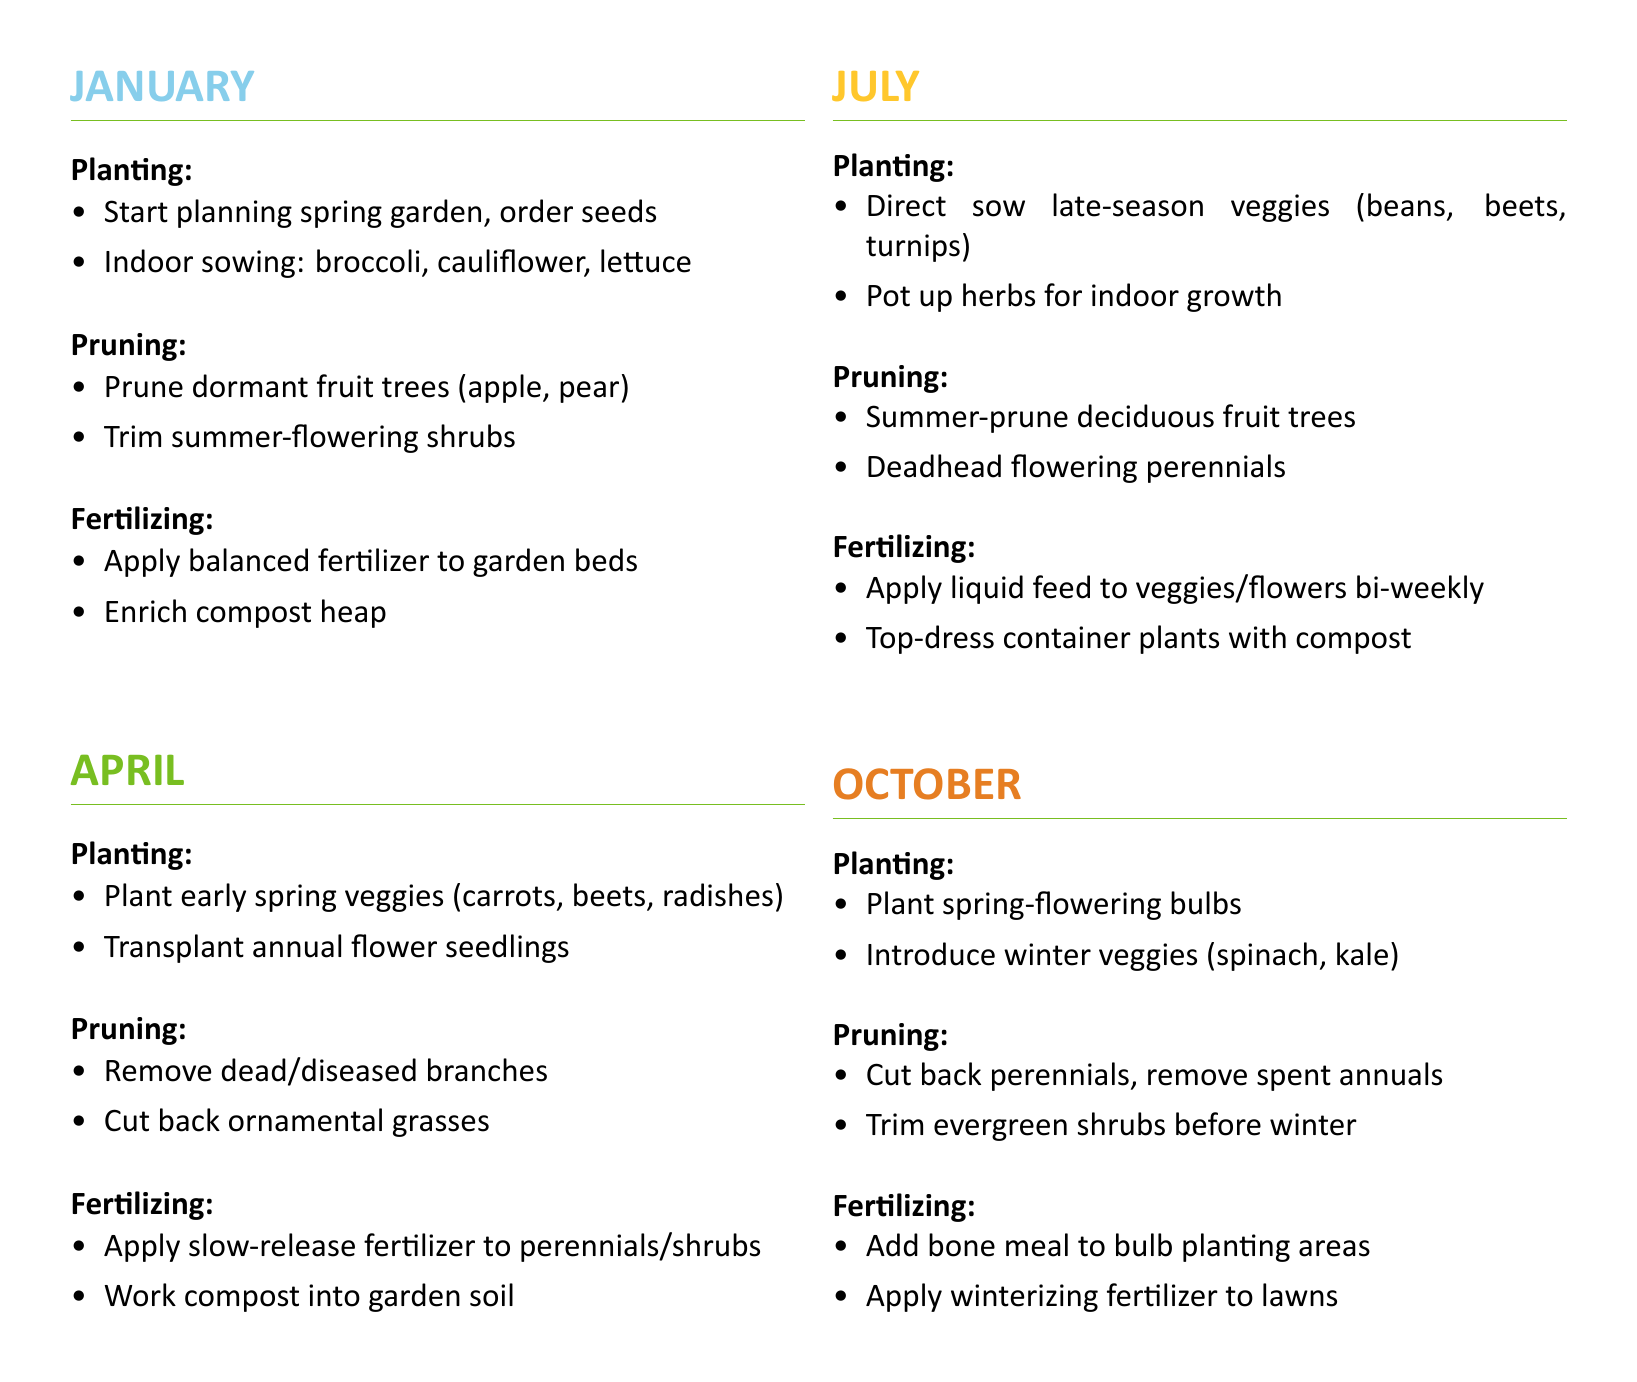What should be sown indoors in January? The document lists broccoli, cauliflower, and lettuce as seeds for indoor sowing in January.
Answer: broccoli, cauliflower, lettuce Which month is associated with planting spring-flowering bulbs? The document indicates that October is the time for planting spring-flowering bulbs.
Answer: October What type of fertilizer is recommended for perennials in April? The document states that a slow-release fertilizer should be applied to perennials and shrubs in April.
Answer: slow-release fertilizer How many times should liquid feed be applied in July? According to the document, liquid feed should be applied bi-weekly to veggies and flowers in July, which indicates every two weeks.
Answer: bi-weekly What gardening task is suggested for summer-flowering shrubs in January? The document suggests pruning summer-flowering shrubs as a task in January.
Answer: Prune Which two types of vegetables can be introduced in October? The document mentions spinach and kale as winter veggies to introduce in October.
Answer: spinach, kale What task is advised for evergreen shrubs before winter? The document advises trimming evergreen shrubs before winter in October.
Answer: Trim What activity is suggested for compost in January? The document notes that enriching the compost heap is a suggested activity in January.
Answer: Enrich compost heap Which month involves planting carrots, beets, and radishes? The planting of early spring veggies such as carrots, beets, and radishes is scheduled for April.
Answer: April 